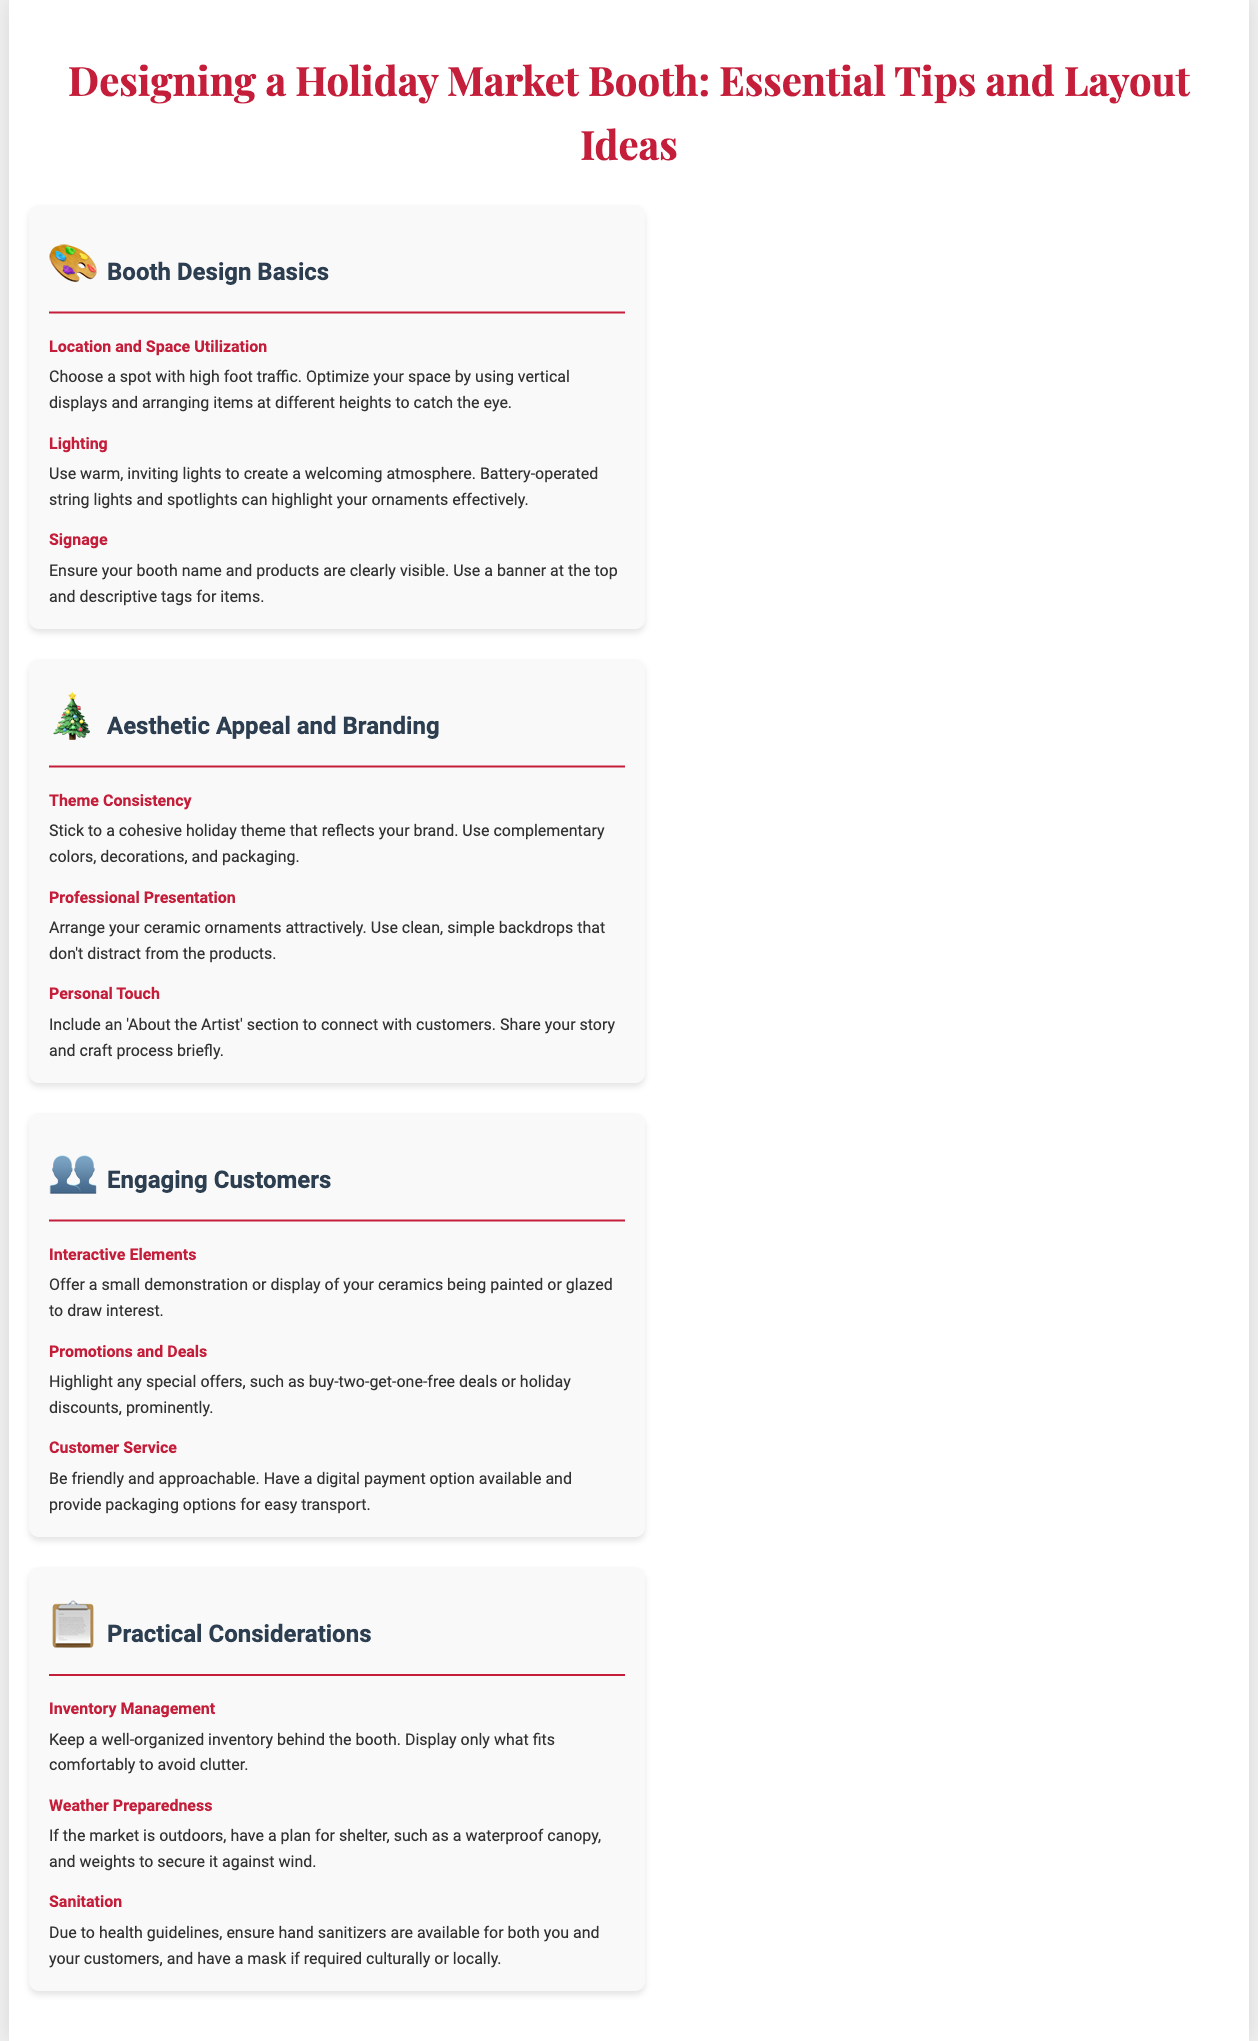What is the main focus of the infographic? The main focus of the infographic is to provide essential tips and layout ideas for designing a holiday market booth.
Answer: Designing a Holiday Market Booth: Essential Tips and Layout Ideas What should be used for creating a welcoming atmosphere? The infographic suggests using warm, inviting lights for a welcoming atmosphere.
Answer: Warm, inviting lights What is a recommended way to display items? The document recommends using vertical displays and arranging items at different heights to catch the eye.
Answer: Vertical displays Which section includes a suggestion for promotions? The suggestion for promotions is found in the "Engaging Customers" section.
Answer: Engaging Customers What is a practical consideration for outdoor markets? A practical consideration for outdoor markets is having a waterproof canopy for shelter.
Answer: Waterproof canopy How should the theme of the booth be described? The theme of the booth should be described as cohesive and reflecting the brand.
Answer: Cohesive holiday theme What is one suggested interactive element to engage customers? One suggested interactive element is to offer a small demonstration of ceramics being painted or glazed.
Answer: Small demonstration What aspect of customer interaction is emphasized? The emphasis is on friendly and approachable customer service.
Answer: Customer service What is an essential item to have for sanitation? It is essential to have hand sanitizers available for both you and your customers.
Answer: Hand sanitizers 